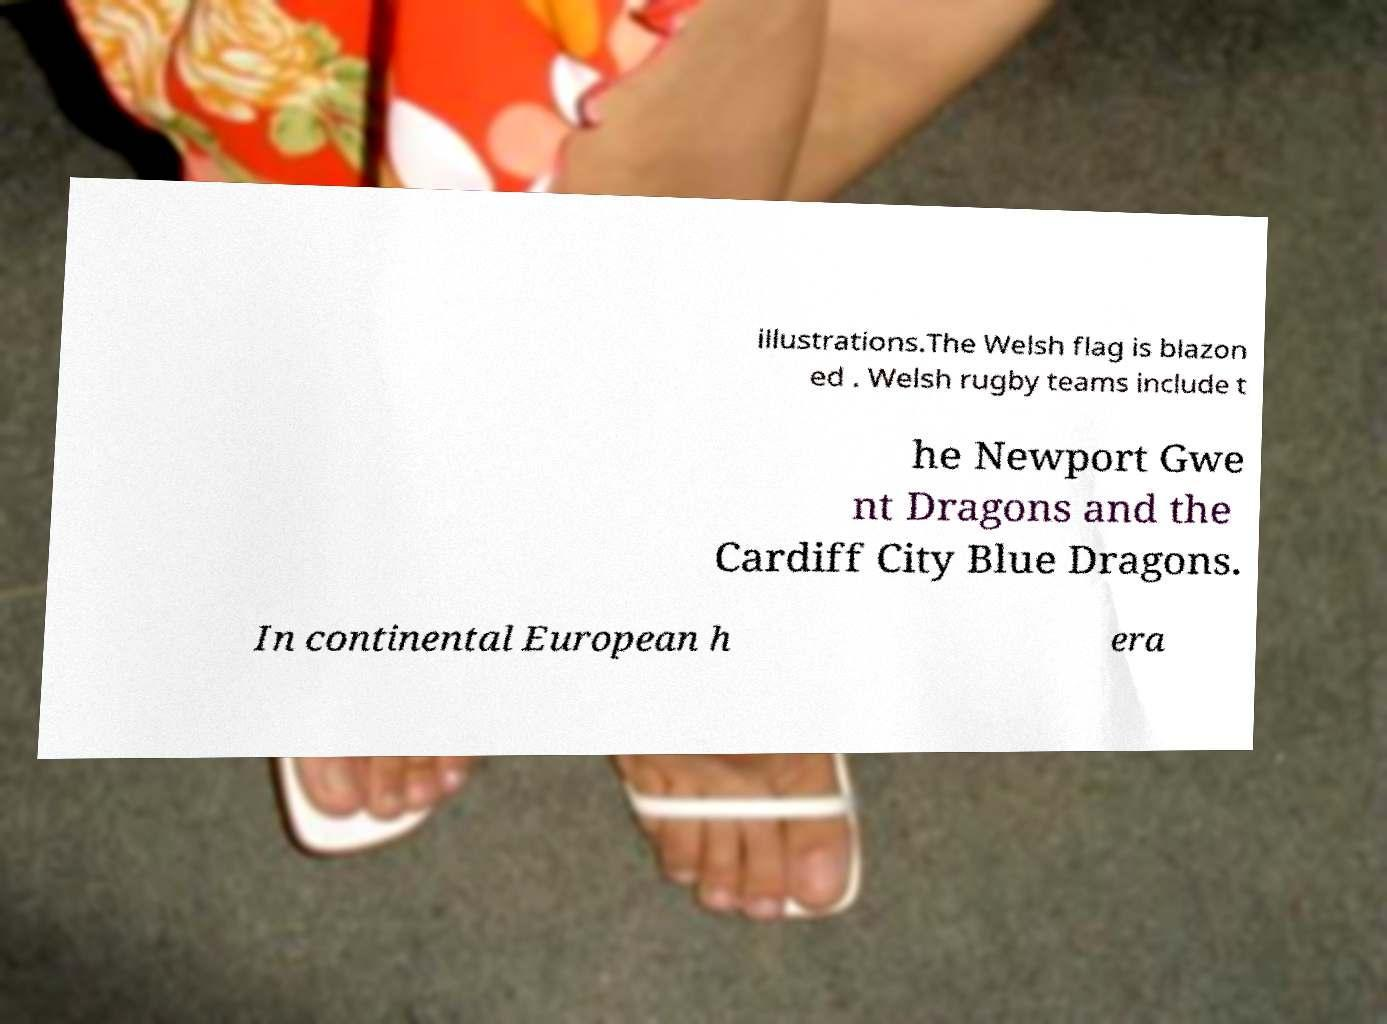What messages or text are displayed in this image? I need them in a readable, typed format. illustrations.The Welsh flag is blazon ed . Welsh rugby teams include t he Newport Gwe nt Dragons and the Cardiff City Blue Dragons. In continental European h era 